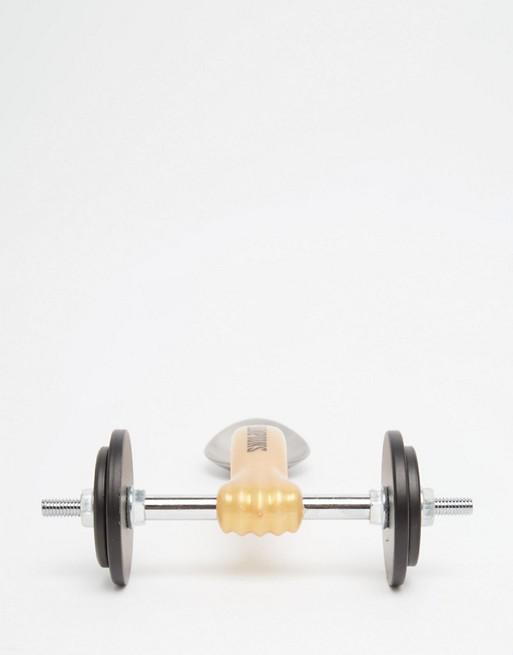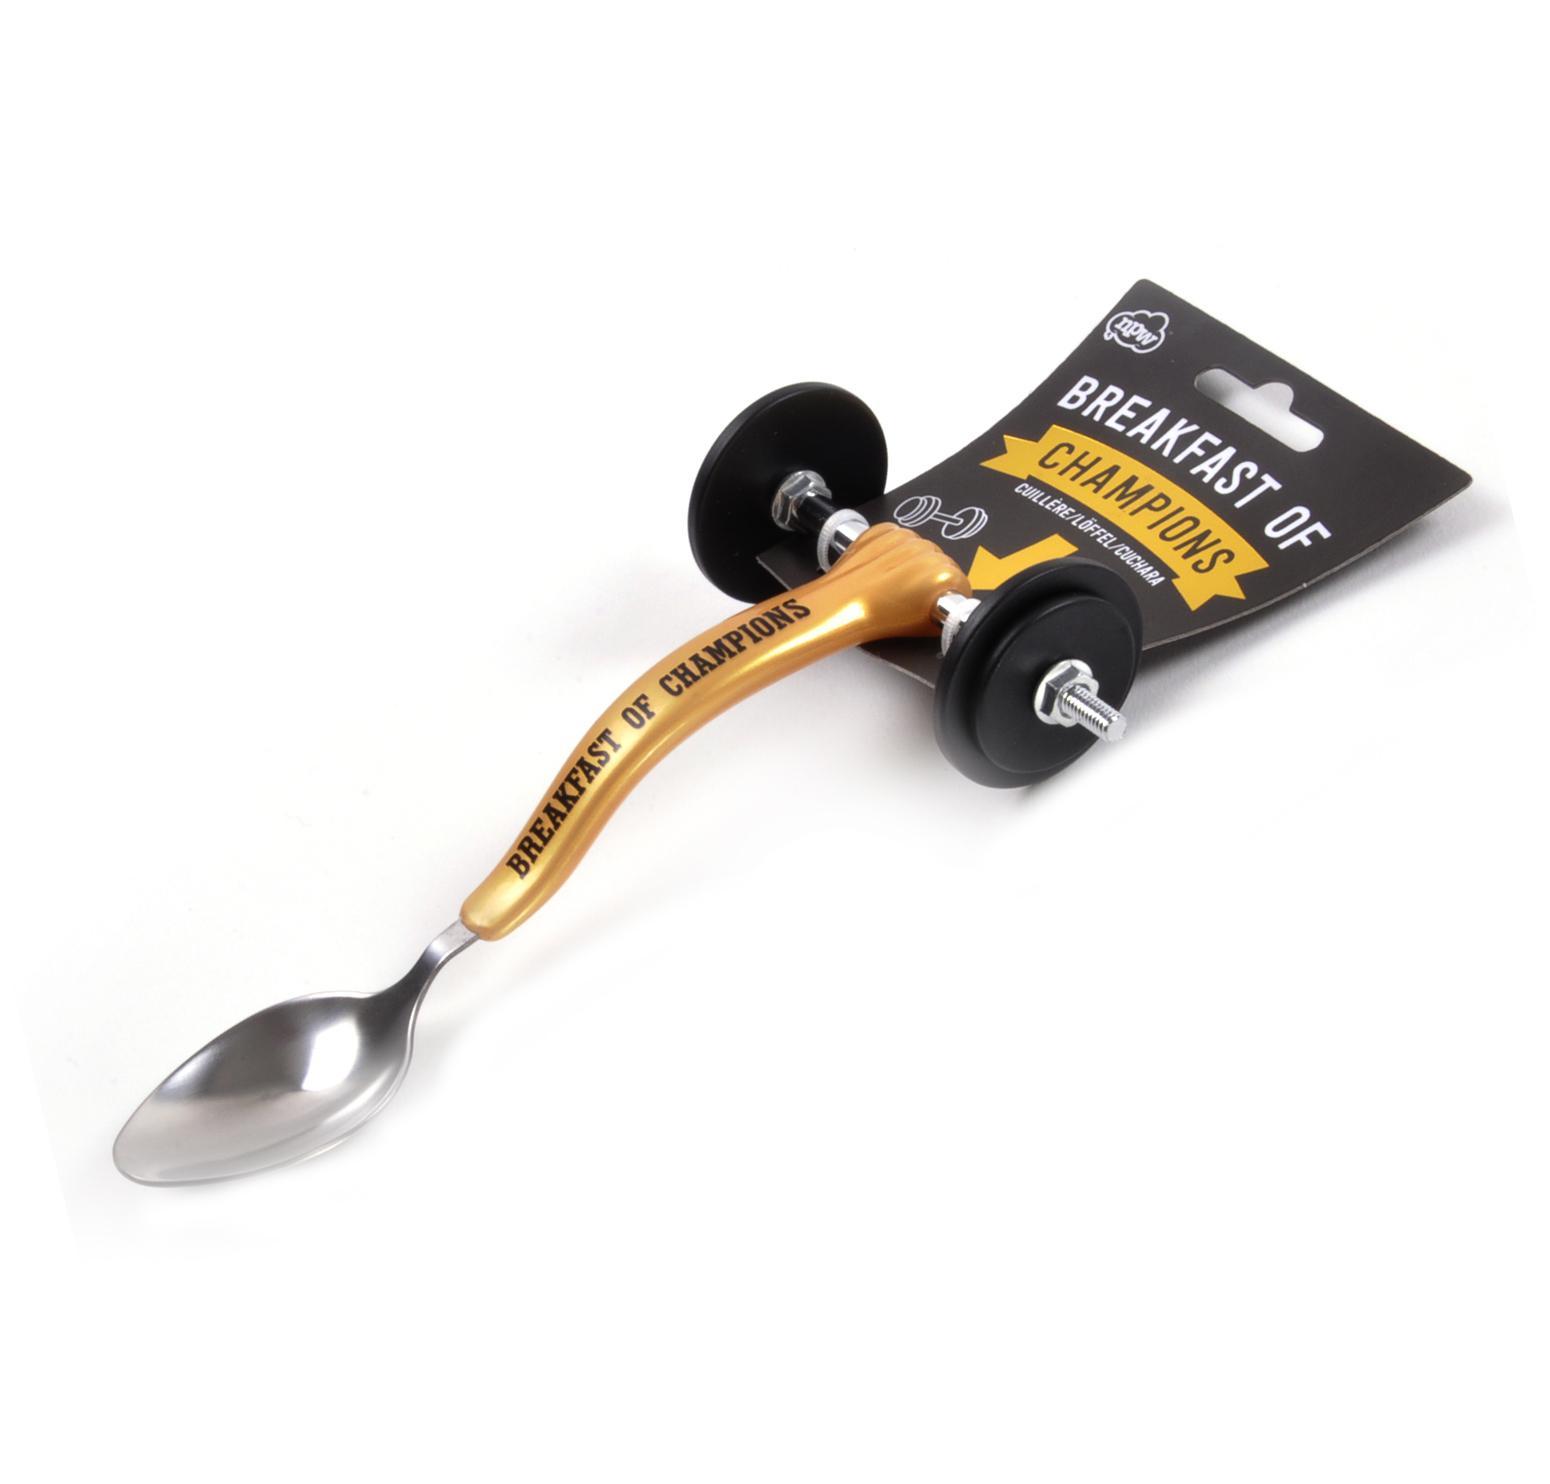The first image is the image on the left, the second image is the image on the right. Analyze the images presented: Is the assertion "The spoon is turned toward the bottom left in one of the images." valid? Answer yes or no. Yes. 